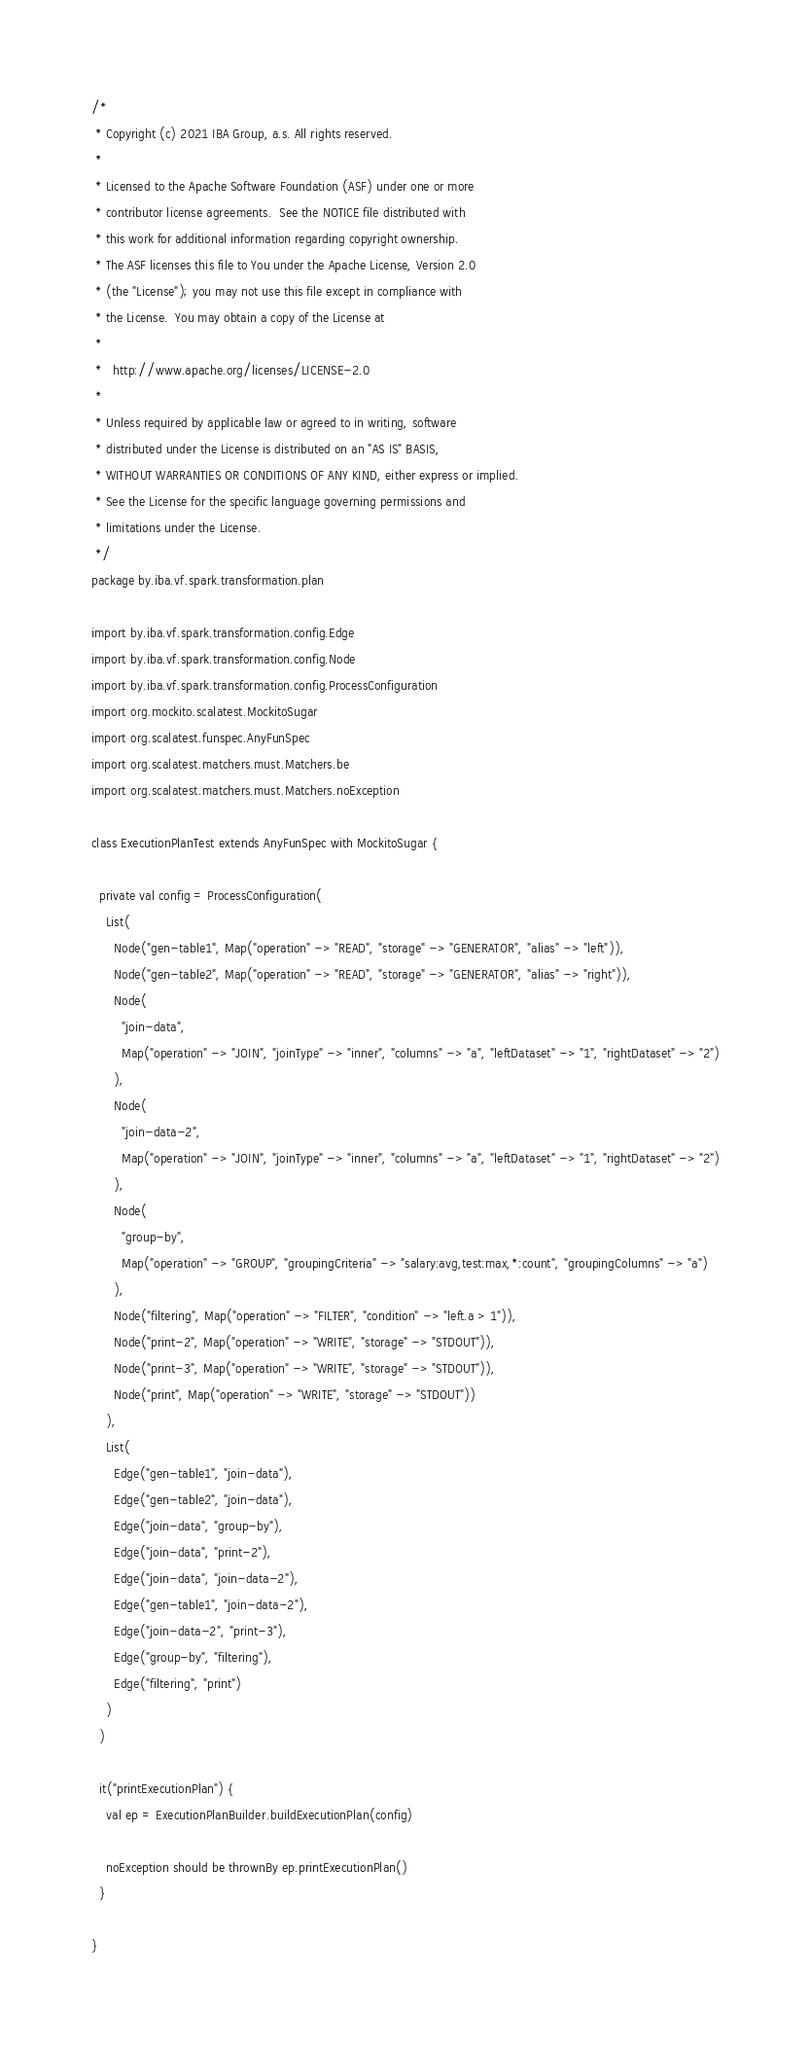Convert code to text. <code><loc_0><loc_0><loc_500><loc_500><_Scala_>/*
 * Copyright (c) 2021 IBA Group, a.s. All rights reserved.
 *
 * Licensed to the Apache Software Foundation (ASF) under one or more
 * contributor license agreements.  See the NOTICE file distributed with
 * this work for additional information regarding copyright ownership.
 * The ASF licenses this file to You under the Apache License, Version 2.0
 * (the "License"); you may not use this file except in compliance with
 * the License.  You may obtain a copy of the License at
 *
 *   http://www.apache.org/licenses/LICENSE-2.0
 *
 * Unless required by applicable law or agreed to in writing, software
 * distributed under the License is distributed on an "AS IS" BASIS,
 * WITHOUT WARRANTIES OR CONDITIONS OF ANY KIND, either express or implied.
 * See the License for the specific language governing permissions and
 * limitations under the License.
 */
package by.iba.vf.spark.transformation.plan

import by.iba.vf.spark.transformation.config.Edge
import by.iba.vf.spark.transformation.config.Node
import by.iba.vf.spark.transformation.config.ProcessConfiguration
import org.mockito.scalatest.MockitoSugar
import org.scalatest.funspec.AnyFunSpec
import org.scalatest.matchers.must.Matchers.be
import org.scalatest.matchers.must.Matchers.noException

class ExecutionPlanTest extends AnyFunSpec with MockitoSugar {

  private val config = ProcessConfiguration(
    List(
      Node("gen-table1", Map("operation" -> "READ", "storage" -> "GENERATOR", "alias" -> "left")),
      Node("gen-table2", Map("operation" -> "READ", "storage" -> "GENERATOR", "alias" -> "right")),
      Node(
        "join-data",
        Map("operation" -> "JOIN", "joinType" -> "inner", "columns" -> "a", "leftDataset" -> "1", "rightDataset" -> "2")
      ),
      Node(
        "join-data-2",
        Map("operation" -> "JOIN", "joinType" -> "inner", "columns" -> "a", "leftDataset" -> "1", "rightDataset" -> "2")
      ),
      Node(
        "group-by",
        Map("operation" -> "GROUP", "groupingCriteria" -> "salary:avg,test:max,*:count", "groupingColumns" -> "a")
      ),
      Node("filtering", Map("operation" -> "FILTER", "condition" -> "left.a > 1")),
      Node("print-2", Map("operation" -> "WRITE", "storage" -> "STDOUT")),
      Node("print-3", Map("operation" -> "WRITE", "storage" -> "STDOUT")),
      Node("print", Map("operation" -> "WRITE", "storage" -> "STDOUT"))
    ),
    List(
      Edge("gen-table1", "join-data"),
      Edge("gen-table2", "join-data"),
      Edge("join-data", "group-by"),
      Edge("join-data", "print-2"),
      Edge("join-data", "join-data-2"),
      Edge("gen-table1", "join-data-2"),
      Edge("join-data-2", "print-3"),
      Edge("group-by", "filtering"),
      Edge("filtering", "print")
    )
  )

  it("printExecutionPlan") {
    val ep = ExecutionPlanBuilder.buildExecutionPlan(config)

    noException should be thrownBy ep.printExecutionPlan()
  }

}
</code> 